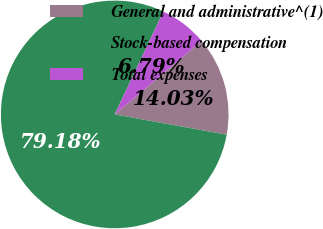<chart> <loc_0><loc_0><loc_500><loc_500><pie_chart><fcel>General and administrative^(1)<fcel>Stock-based compensation<fcel>Total expenses<nl><fcel>14.03%<fcel>79.19%<fcel>6.79%<nl></chart> 